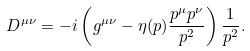<formula> <loc_0><loc_0><loc_500><loc_500>D ^ { \mu \nu } = - i \left ( g ^ { \mu \nu } - \eta ( p ) \frac { p ^ { \mu } p ^ { \nu } } { p ^ { 2 } } \right ) \frac { 1 } { p ^ { 2 } } .</formula> 